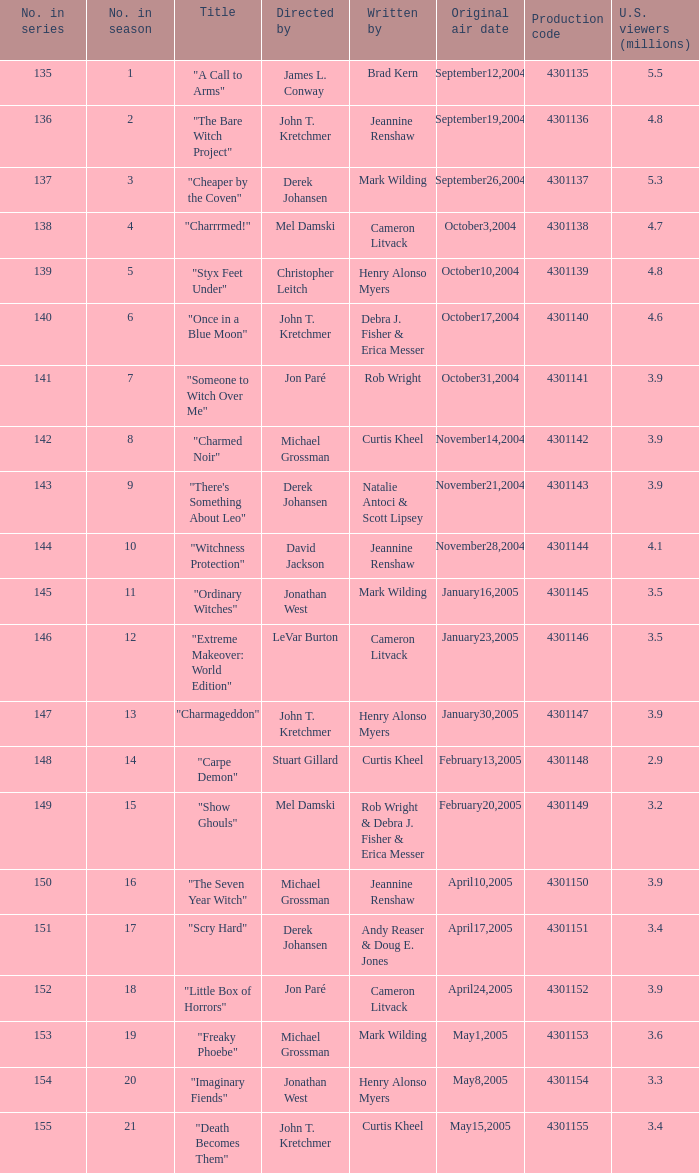When the writer is brad kern, how many u.s viewers (in millions) had the episode? 5.5. 